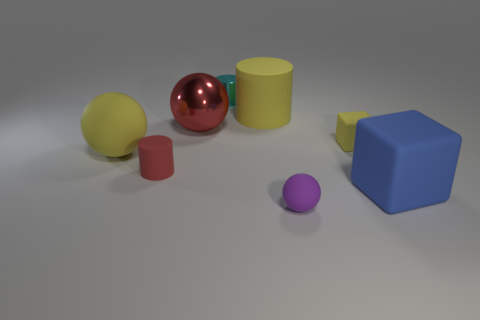How might the different sizes of objects influence our perception of depth in this image? The various sizes of objects in the image contribute to a sense of depth through the concept of perspective. Larger objects tend to appear closer to the viewer, while smaller objects appear further away. This aids in creating a three-dimensional perception in what is essentially a two-dimensional image. 